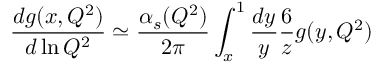<formula> <loc_0><loc_0><loc_500><loc_500>\frac { d g ( x , Q ^ { 2 } ) } { d \ln Q ^ { 2 } } \simeq \frac { \alpha _ { s } ( Q ^ { 2 } ) } { 2 \pi } \int _ { x } ^ { 1 } \frac { d y } { y } \frac { 6 } { z } g ( y , Q ^ { 2 } )</formula> 